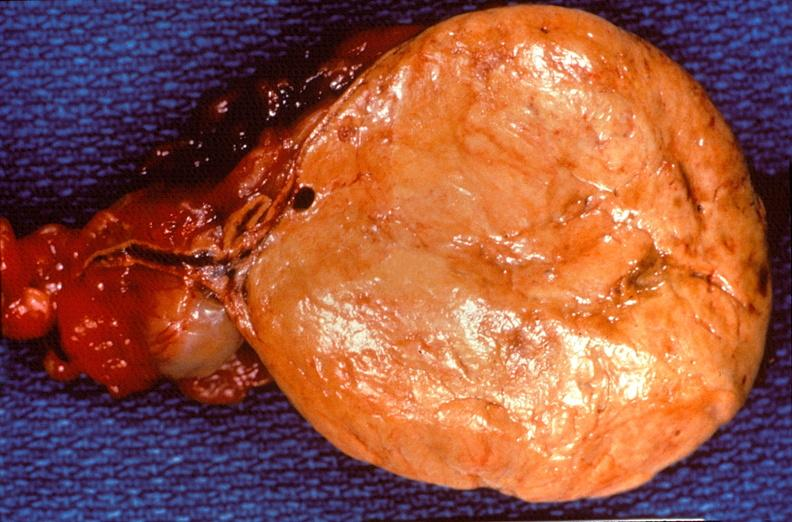s endocrine present?
Answer the question using a single word or phrase. Yes 